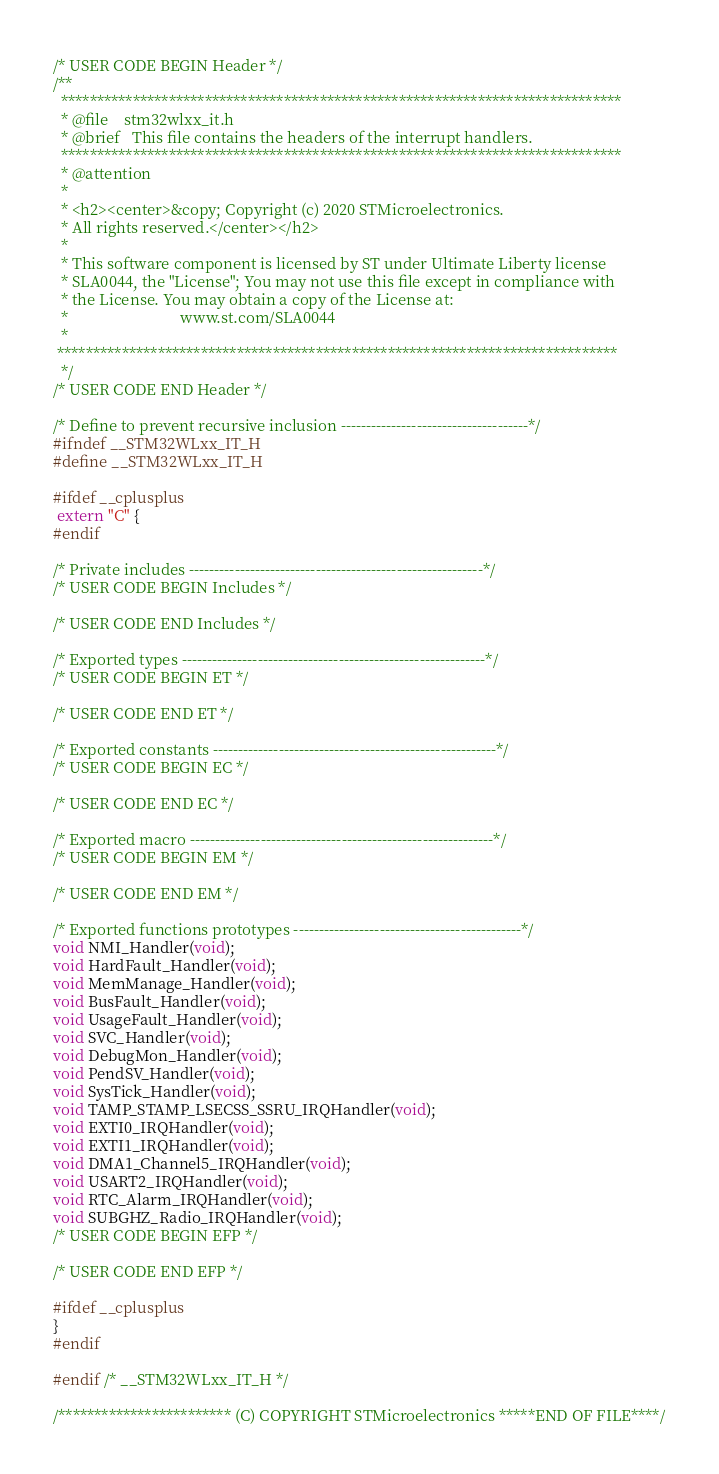<code> <loc_0><loc_0><loc_500><loc_500><_C_>/* USER CODE BEGIN Header */
/**
  ******************************************************************************
  * @file    stm32wlxx_it.h
  * @brief   This file contains the headers of the interrupt handlers.
  ******************************************************************************
  * @attention
  *
  * <h2><center>&copy; Copyright (c) 2020 STMicroelectronics.
  * All rights reserved.</center></h2>
  *
  * This software component is licensed by ST under Ultimate Liberty license
  * SLA0044, the "License"; You may not use this file except in compliance with
  * the License. You may obtain a copy of the License at:
  *                             www.st.com/SLA0044
  *
 ******************************************************************************
  */
/* USER CODE END Header */

/* Define to prevent recursive inclusion -------------------------------------*/
#ifndef __STM32WLxx_IT_H
#define __STM32WLxx_IT_H

#ifdef __cplusplus
 extern "C" {
#endif

/* Private includes ----------------------------------------------------------*/
/* USER CODE BEGIN Includes */

/* USER CODE END Includes */

/* Exported types ------------------------------------------------------------*/
/* USER CODE BEGIN ET */

/* USER CODE END ET */

/* Exported constants --------------------------------------------------------*/
/* USER CODE BEGIN EC */

/* USER CODE END EC */

/* Exported macro ------------------------------------------------------------*/
/* USER CODE BEGIN EM */

/* USER CODE END EM */

/* Exported functions prototypes ---------------------------------------------*/
void NMI_Handler(void);
void HardFault_Handler(void);
void MemManage_Handler(void);
void BusFault_Handler(void);
void UsageFault_Handler(void);
void SVC_Handler(void);
void DebugMon_Handler(void);
void PendSV_Handler(void);
void SysTick_Handler(void);
void TAMP_STAMP_LSECSS_SSRU_IRQHandler(void);
void EXTI0_IRQHandler(void);
void EXTI1_IRQHandler(void);
void DMA1_Channel5_IRQHandler(void);
void USART2_IRQHandler(void);
void RTC_Alarm_IRQHandler(void);
void SUBGHZ_Radio_IRQHandler(void);
/* USER CODE BEGIN EFP */

/* USER CODE END EFP */

#ifdef __cplusplus
}
#endif

#endif /* __STM32WLxx_IT_H */

/************************ (C) COPYRIGHT STMicroelectronics *****END OF FILE****/
</code> 